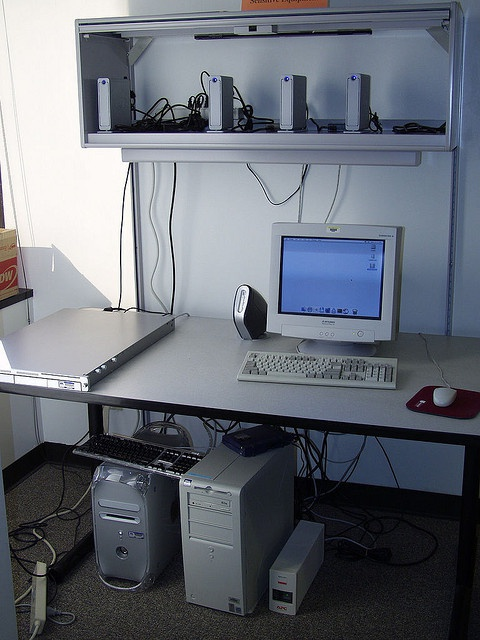Describe the objects in this image and their specific colors. I can see tv in ivory, gray, and darkgray tones, laptop in ivory, darkgray, white, and gray tones, keyboard in ivory, gray, darkgray, and black tones, and mouse in ivory, gray, and black tones in this image. 